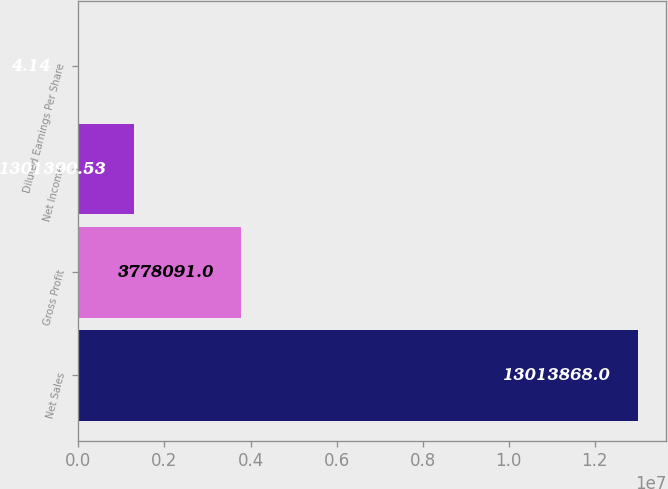Convert chart to OTSL. <chart><loc_0><loc_0><loc_500><loc_500><bar_chart><fcel>Net Sales<fcel>Gross Profit<fcel>Net Income<fcel>Diluted Earnings Per Share<nl><fcel>1.30139e+07<fcel>3.77809e+06<fcel>1.30139e+06<fcel>4.14<nl></chart> 